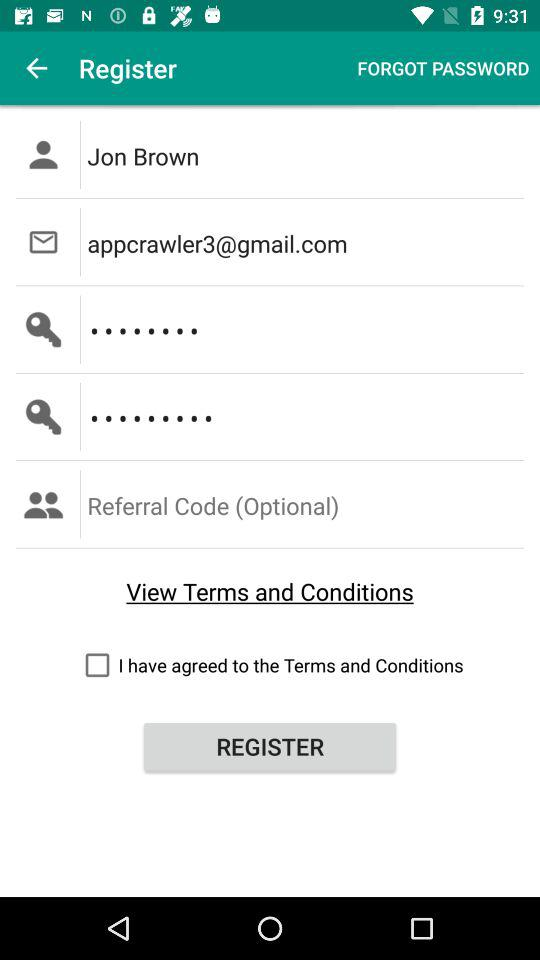Is the referral code optional or mandatory? The referral code is optional. 